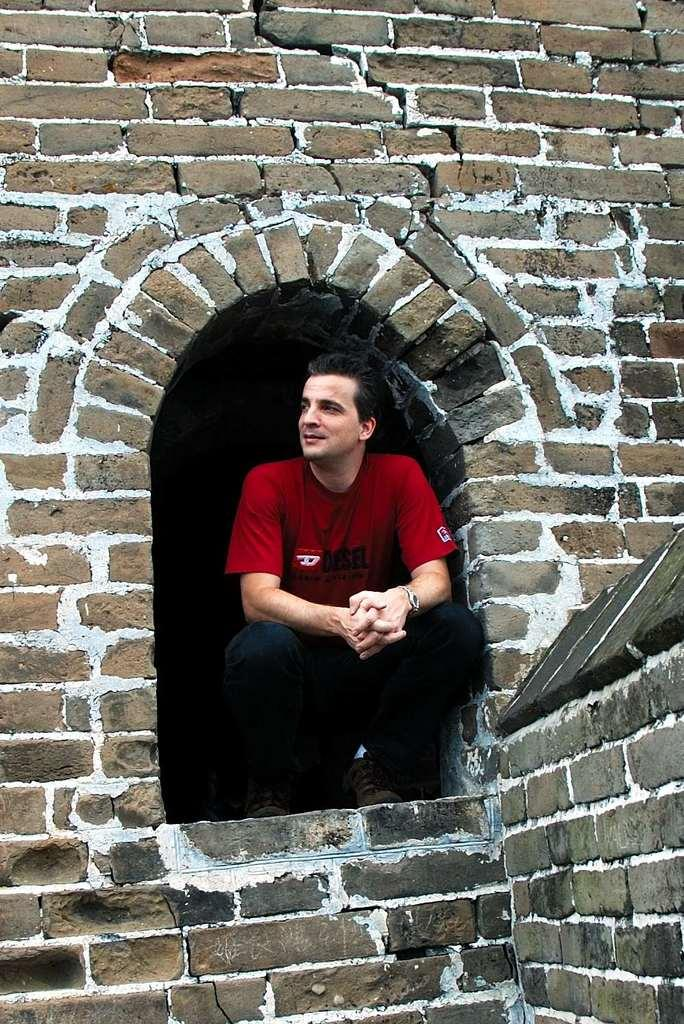Who is present in the image? There is a man in the image. What is the man wearing? The man is wearing a red t-shirt. Where is the man located in the image? The man is in the middle of a brick wall. What type of test is the man taking in the image? There is no indication in the image that the man is taking a test. 